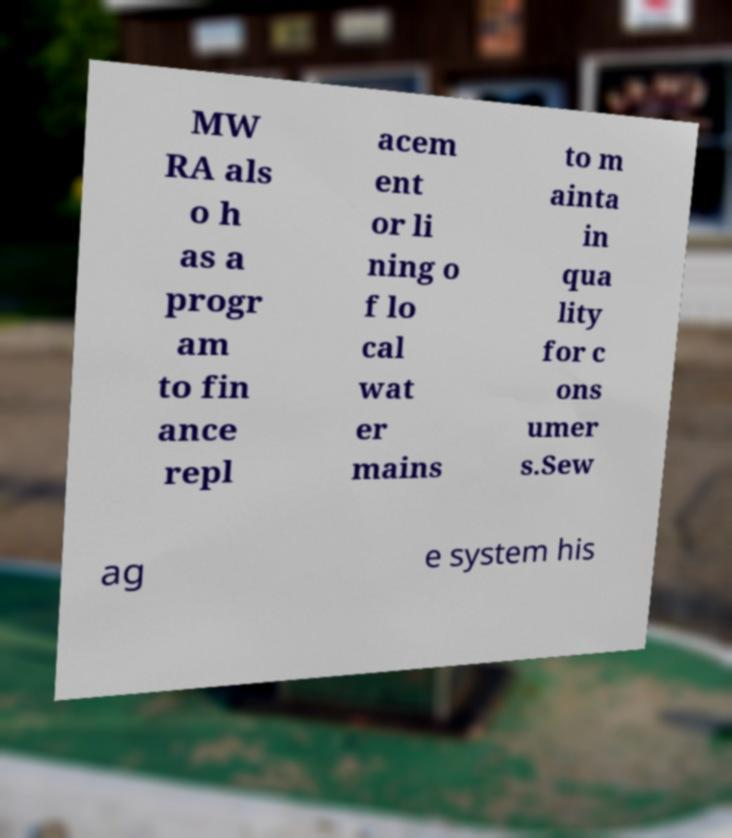There's text embedded in this image that I need extracted. Can you transcribe it verbatim? MW RA als o h as a progr am to fin ance repl acem ent or li ning o f lo cal wat er mains to m ainta in qua lity for c ons umer s.Sew ag e system his 